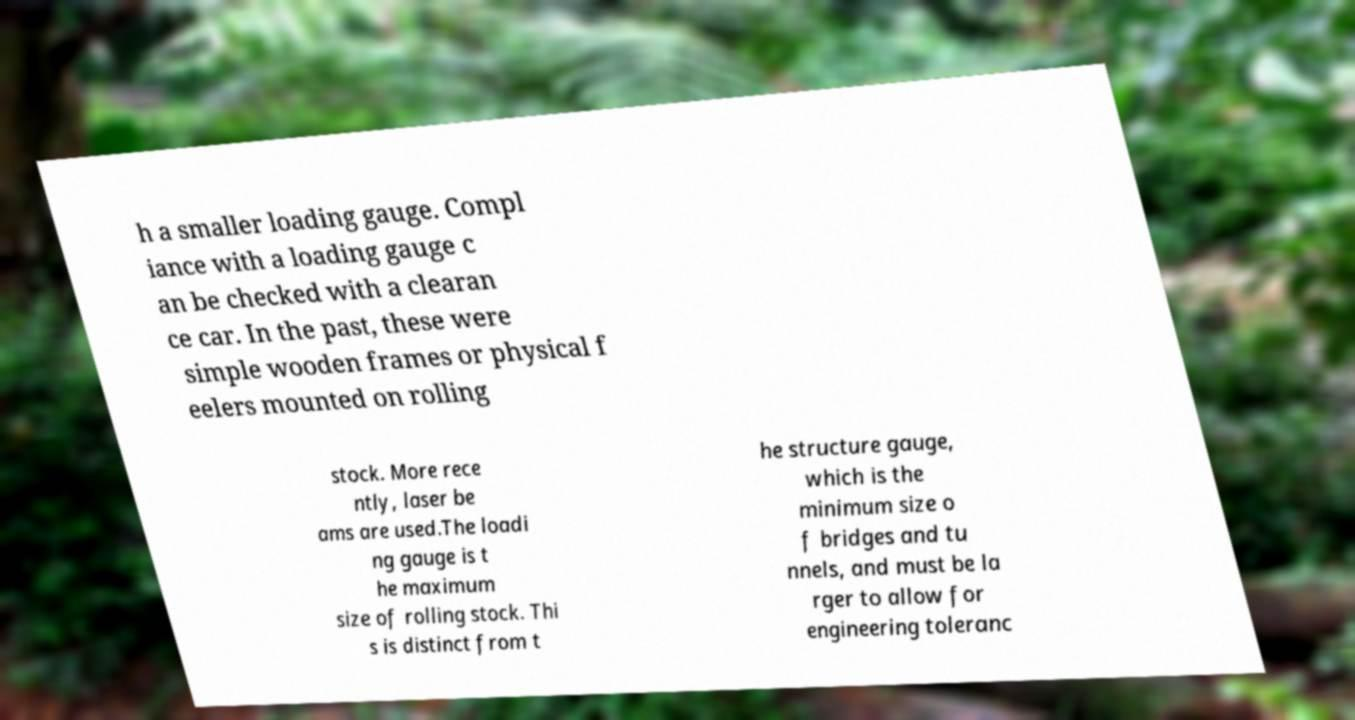Please read and relay the text visible in this image. What does it say? h a smaller loading gauge. Compl iance with a loading gauge c an be checked with a clearan ce car. In the past, these were simple wooden frames or physical f eelers mounted on rolling stock. More rece ntly, laser be ams are used.The loadi ng gauge is t he maximum size of rolling stock. Thi s is distinct from t he structure gauge, which is the minimum size o f bridges and tu nnels, and must be la rger to allow for engineering toleranc 